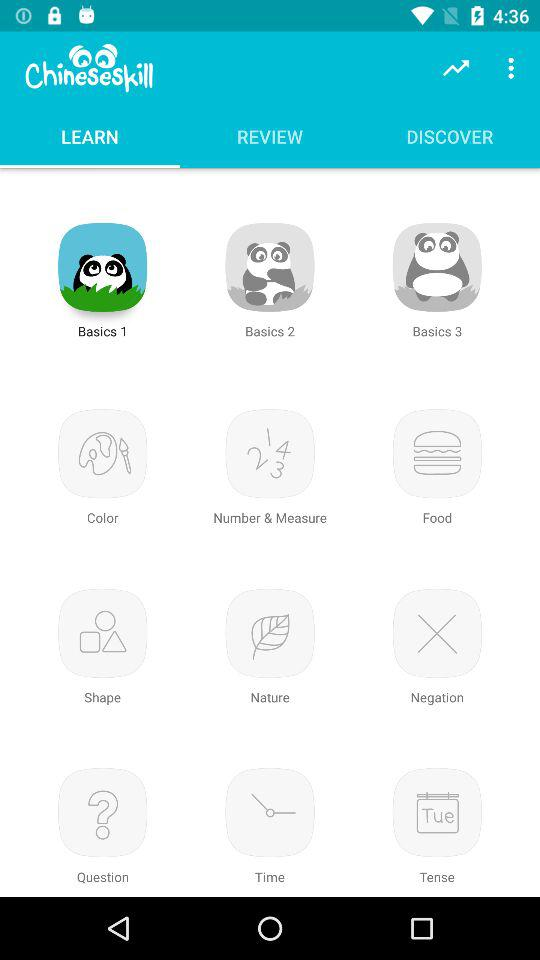How many topics are in the 'Basics' category?
Answer the question using a single word or phrase. 3 